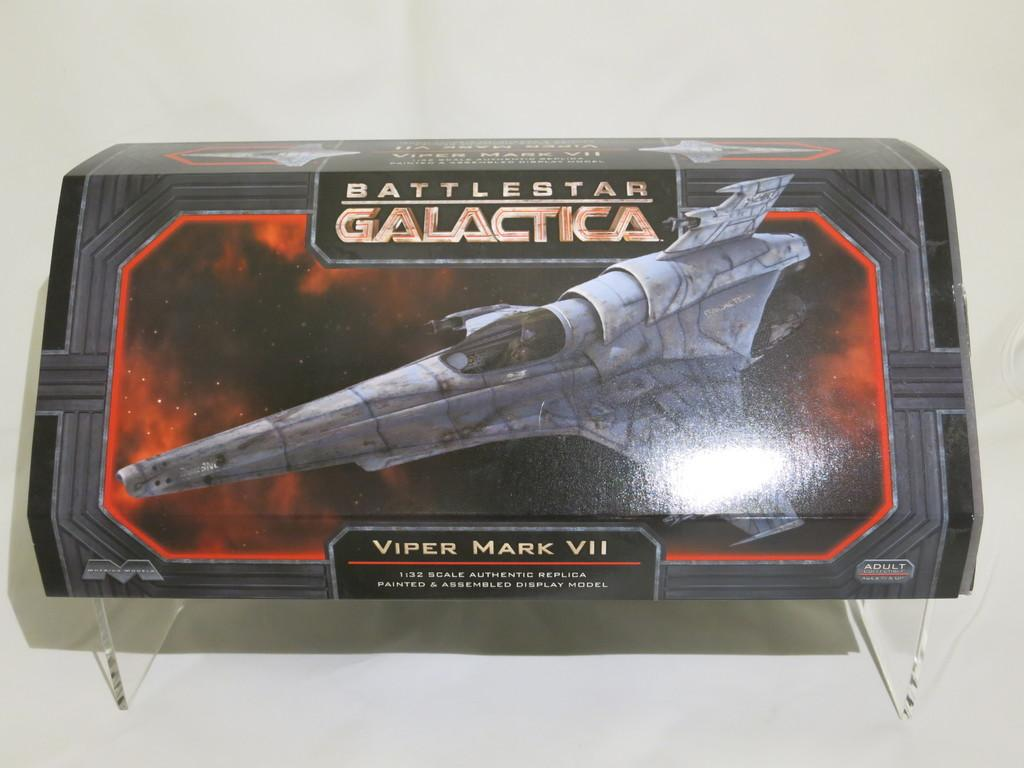<image>
Relay a brief, clear account of the picture shown. A Battlestar Galactica space ship model called the Viper Mark VII is in a grey box. 